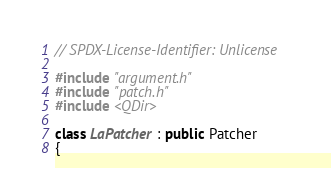<code> <loc_0><loc_0><loc_500><loc_500><_C++_>// SPDX-License-Identifier: Unlicense

#include "argument.h"
#include "patch.h"
#include <QDir>

class LaPatcher : public Patcher
{</code> 